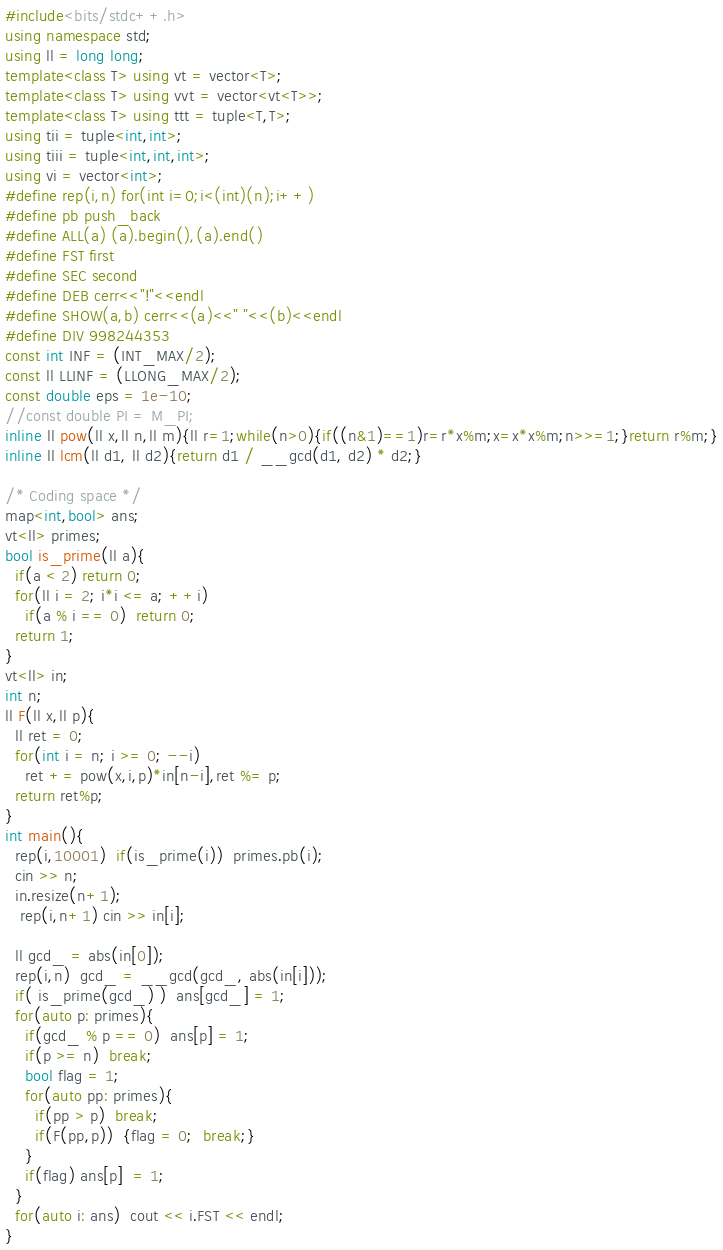Convert code to text. <code><loc_0><loc_0><loc_500><loc_500><_C++_>#include<bits/stdc++.h>
using namespace std;
using ll = long long;
template<class T> using vt = vector<T>;
template<class T> using vvt = vector<vt<T>>;
template<class T> using ttt = tuple<T,T>;
using tii = tuple<int,int>;
using tiii = tuple<int,int,int>;
using vi = vector<int>;
#define rep(i,n) for(int i=0;i<(int)(n);i++)
#define pb push_back
#define ALL(a) (a).begin(),(a).end()
#define FST first
#define SEC second
#define DEB cerr<<"!"<<endl
#define SHOW(a,b) cerr<<(a)<<" "<<(b)<<endl
#define DIV 998244353
const int INF = (INT_MAX/2);
const ll LLINF = (LLONG_MAX/2);
const double eps = 1e-10;
//const double PI = M_PI;  
inline ll pow(ll x,ll n,ll m){ll r=1;while(n>0){if((n&1)==1)r=r*x%m;x=x*x%m;n>>=1;}return r%m;}
inline ll lcm(ll d1, ll d2){return d1 / __gcd(d1, d2) * d2;}

/* Coding space */
map<int,bool> ans;
vt<ll> primes;
bool is_prime(ll a){
  if(a < 2) return 0;
  for(ll i = 2; i*i <= a; ++i)
    if(a % i == 0)  return 0;
  return 1;
}
vt<ll> in;
int n;
ll F(ll x,ll p){
  ll ret = 0;
  for(int i = n; i >= 0; --i)
    ret += pow(x,i,p)*in[n-i],ret %= p;
  return ret%p;
}
int main(){
  rep(i,10001)  if(is_prime(i))  primes.pb(i);
  cin >> n;
  in.resize(n+1);
   rep(i,n+1) cin >> in[i];
  
  ll gcd_ = abs(in[0]);
  rep(i,n)  gcd_ = __gcd(gcd_, abs(in[i]));
  if( is_prime(gcd_) )  ans[gcd_] = 1;
  for(auto p: primes){
    if(gcd_ % p == 0)  ans[p] = 1;
    if(p >= n)  break;
    bool flag = 1;
    for(auto pp: primes){
      if(pp > p)  break;
      if(F(pp,p))  {flag = 0;  break;}
    }
    if(flag) ans[p]  = 1;
  }
  for(auto i: ans)  cout << i.FST << endl;
}
</code> 